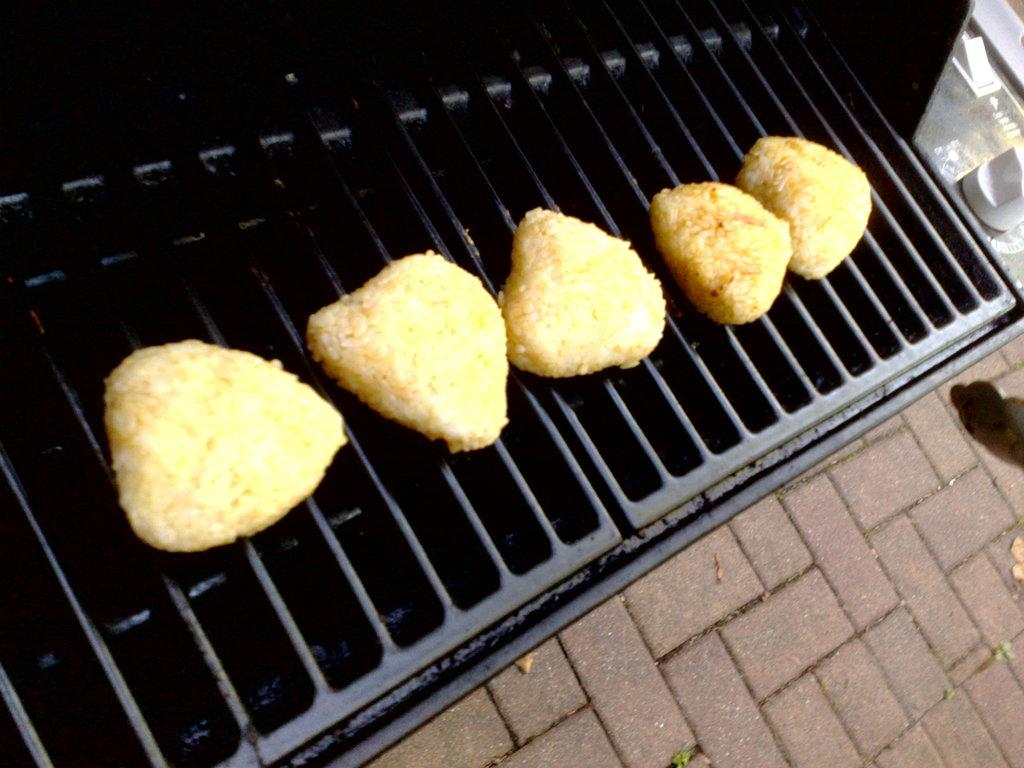What is being cooked in the image? There are food items on grills in the image. Can you describe the surface visible in the bottom right of the image? There is a surface visible in the bottom right of the image, but its specific characteristics are not clear from the provided facts. What is the white object in the top right of the image? There is a white object in the top right of the image, but its specific characteristics are not clear from the provided facts. What type of rhythm is being played by the pin in the image? There is no pin or rhythm present in the image; it features food items on grills and other unspecified elements. 